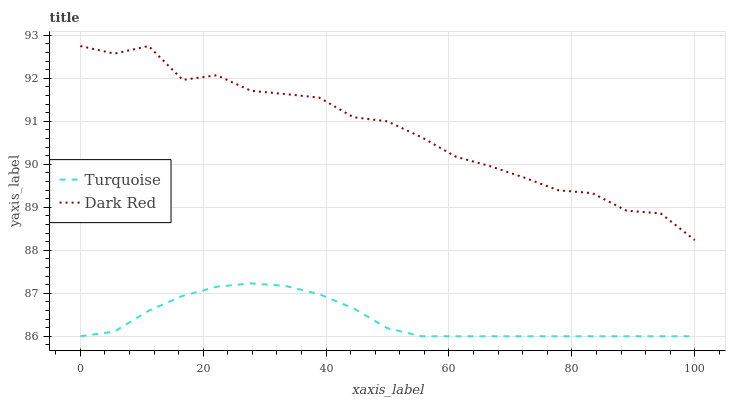Does Turquoise have the minimum area under the curve?
Answer yes or no. Yes. Does Dark Red have the maximum area under the curve?
Answer yes or no. Yes. Does Turquoise have the maximum area under the curve?
Answer yes or no. No. Is Turquoise the smoothest?
Answer yes or no. Yes. Is Dark Red the roughest?
Answer yes or no. Yes. Is Turquoise the roughest?
Answer yes or no. No. Does Turquoise have the lowest value?
Answer yes or no. Yes. Does Dark Red have the highest value?
Answer yes or no. Yes. Does Turquoise have the highest value?
Answer yes or no. No. Is Turquoise less than Dark Red?
Answer yes or no. Yes. Is Dark Red greater than Turquoise?
Answer yes or no. Yes. Does Turquoise intersect Dark Red?
Answer yes or no. No. 